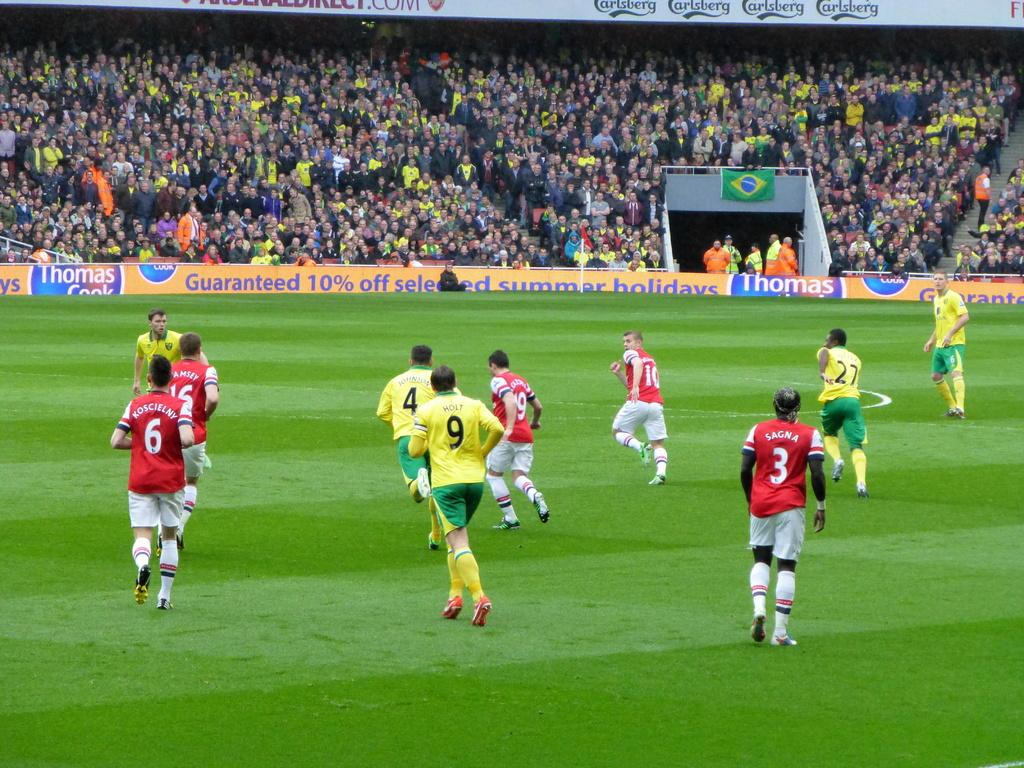<image>
Present a compact description of the photo's key features. soccer game where a sponsor is thomas cook where there is guaranteed 10% off selected summer holidays 